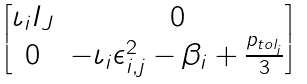Convert formula to latex. <formula><loc_0><loc_0><loc_500><loc_500>\begin{bmatrix} \iota _ { i } I _ { J } & 0 \\ 0 & - \iota _ { i } \epsilon _ { i , j } ^ { 2 } - \beta _ { i } + \frac { p _ { t o l _ { i } } } { 3 } \end{bmatrix}</formula> 